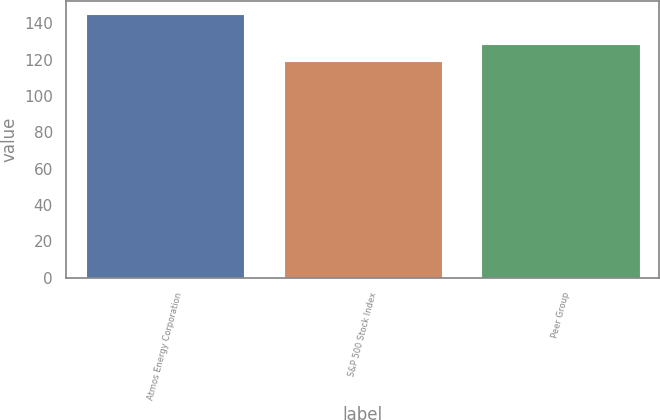Convert chart. <chart><loc_0><loc_0><loc_500><loc_500><bar_chart><fcel>Atmos Energy Corporation<fcel>S&P 500 Stock Index<fcel>Peer Group<nl><fcel>145.03<fcel>119<fcel>128.49<nl></chart> 